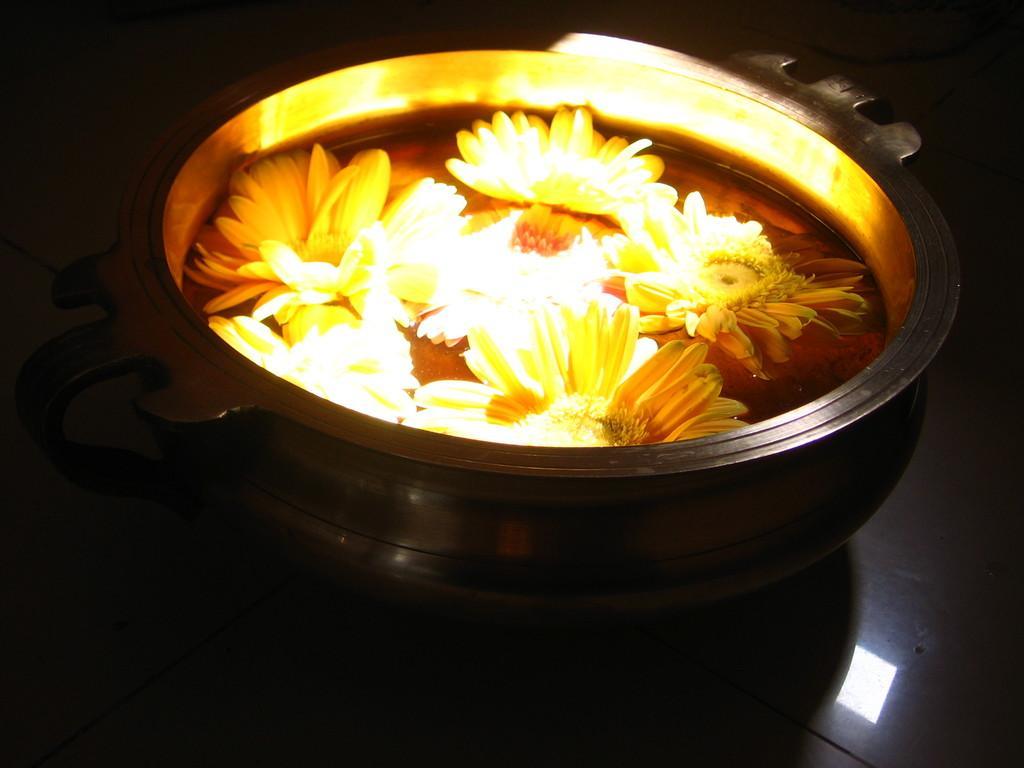Describe this image in one or two sentences. In this image, we can see flowers and there is water in the container and at the bottom, there is a floor. 